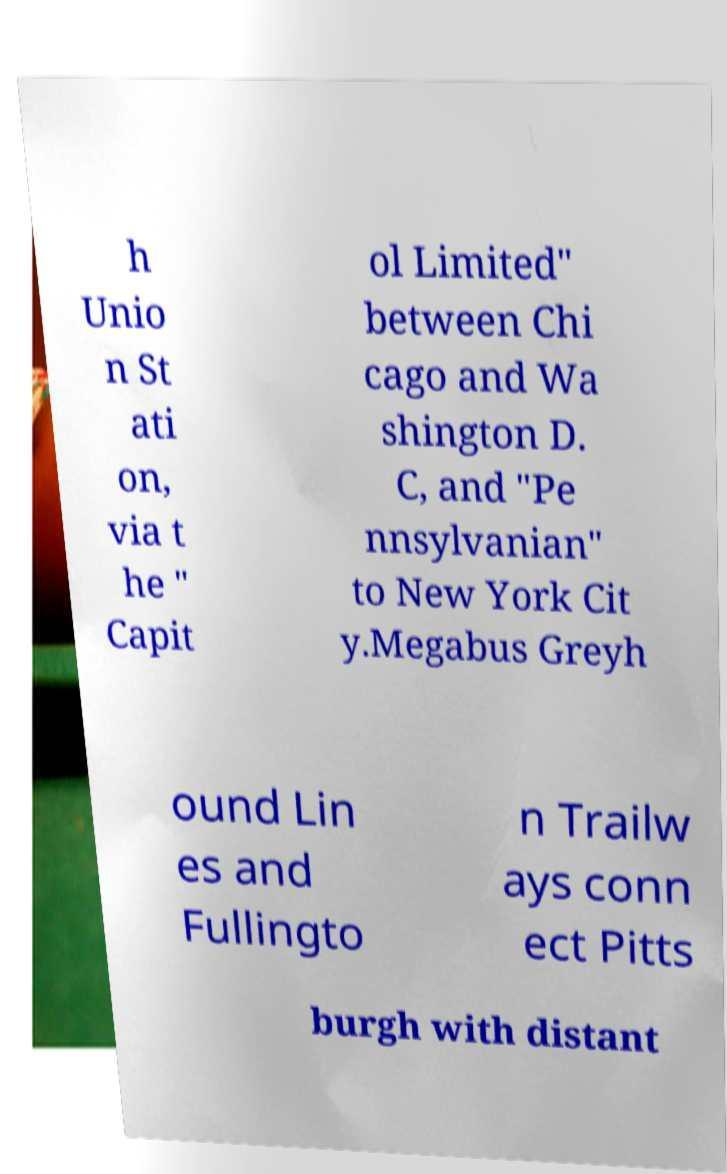Could you assist in decoding the text presented in this image and type it out clearly? h Unio n St ati on, via t he " Capit ol Limited" between Chi cago and Wa shington D. C, and "Pe nnsylvanian" to New York Cit y.Megabus Greyh ound Lin es and Fullingto n Trailw ays conn ect Pitts burgh with distant 